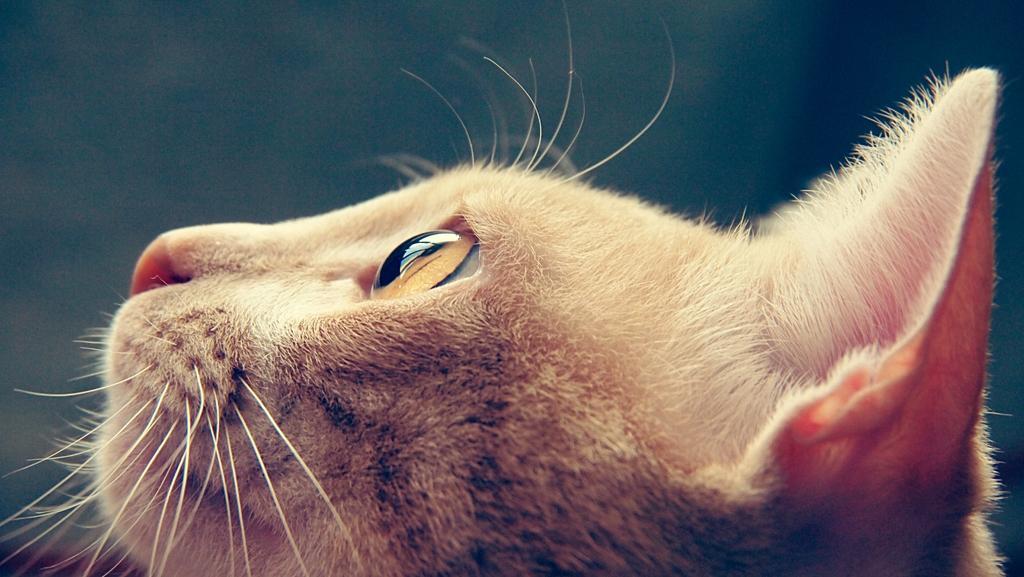Could you give a brief overview of what you see in this image? In this image we can see an animal. 